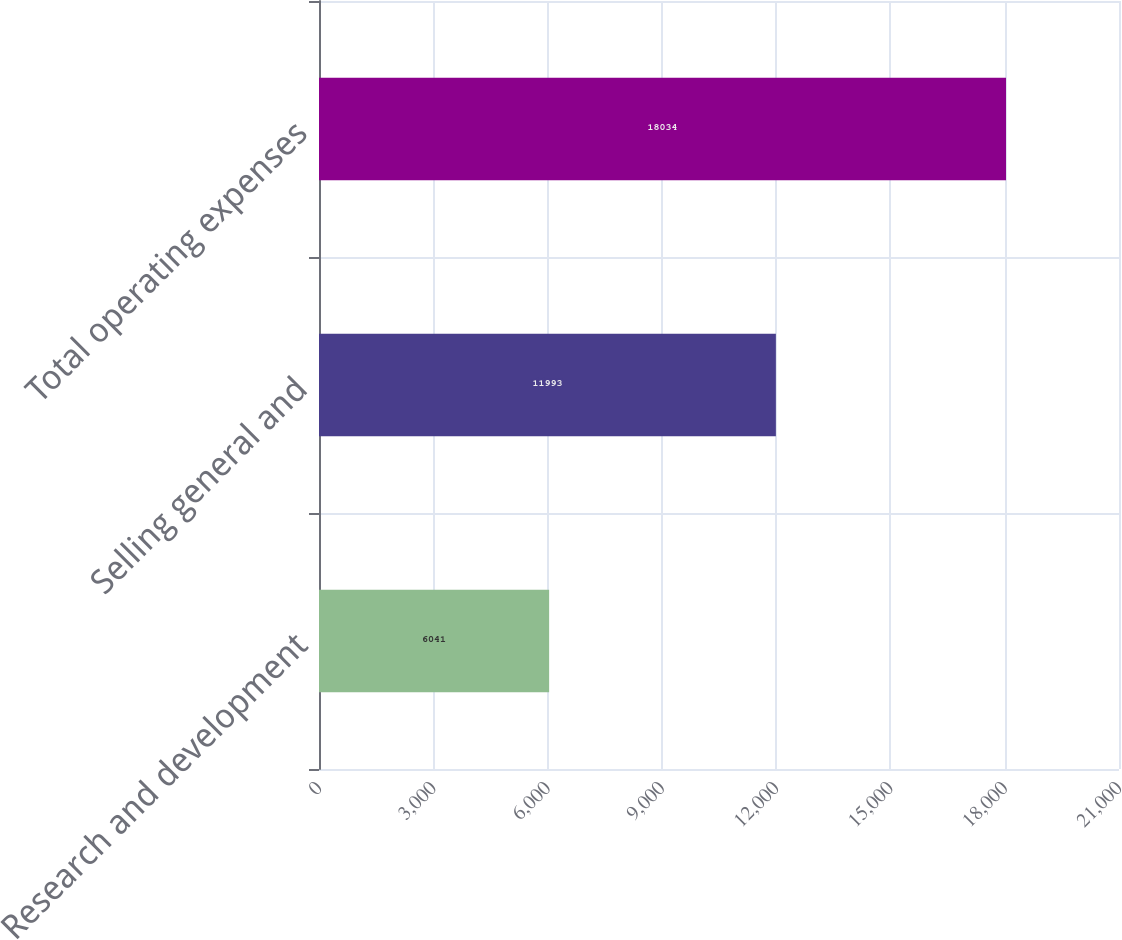<chart> <loc_0><loc_0><loc_500><loc_500><bar_chart><fcel>Research and development<fcel>Selling general and<fcel>Total operating expenses<nl><fcel>6041<fcel>11993<fcel>18034<nl></chart> 